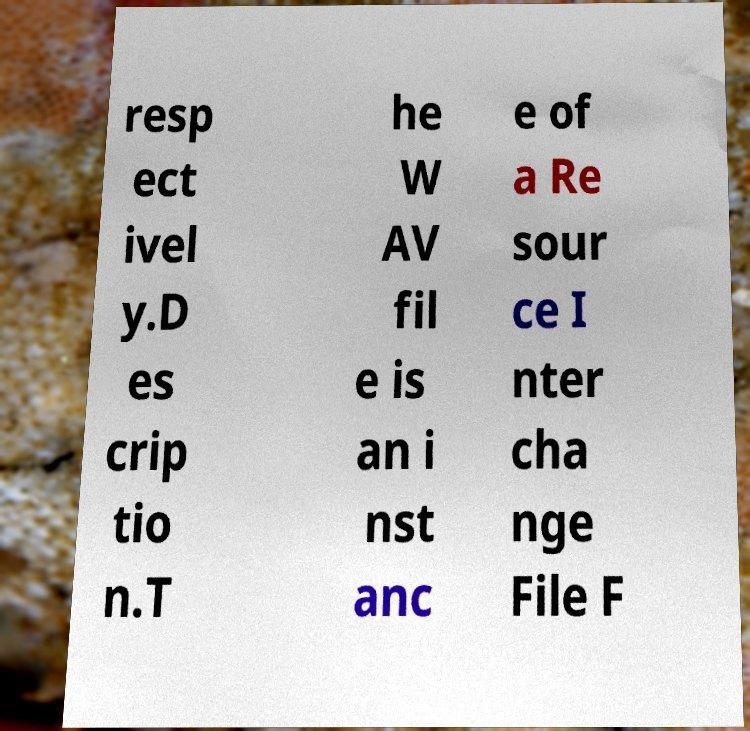Can you read and provide the text displayed in the image?This photo seems to have some interesting text. Can you extract and type it out for me? resp ect ivel y.D es crip tio n.T he W AV fil e is an i nst anc e of a Re sour ce I nter cha nge File F 